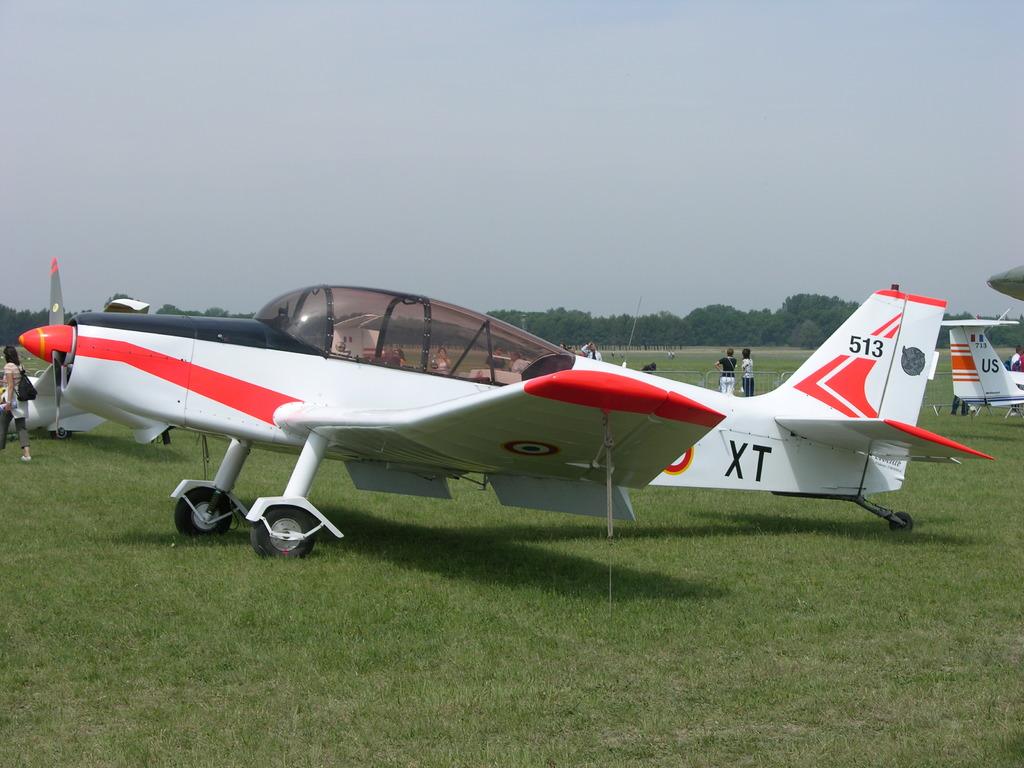What is the id number on the tail of the plane?
Provide a short and direct response. 513. 